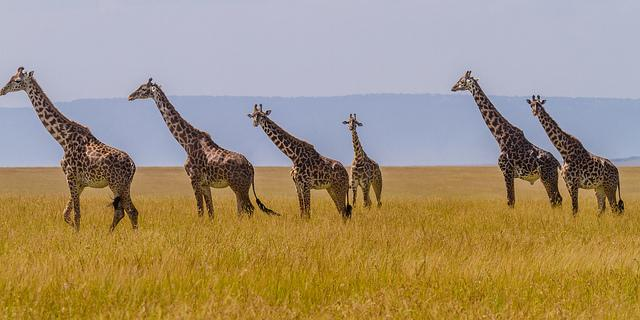How many giraffes are standing up?

Choices:
A) six
B) four
C) three
D) ten six 